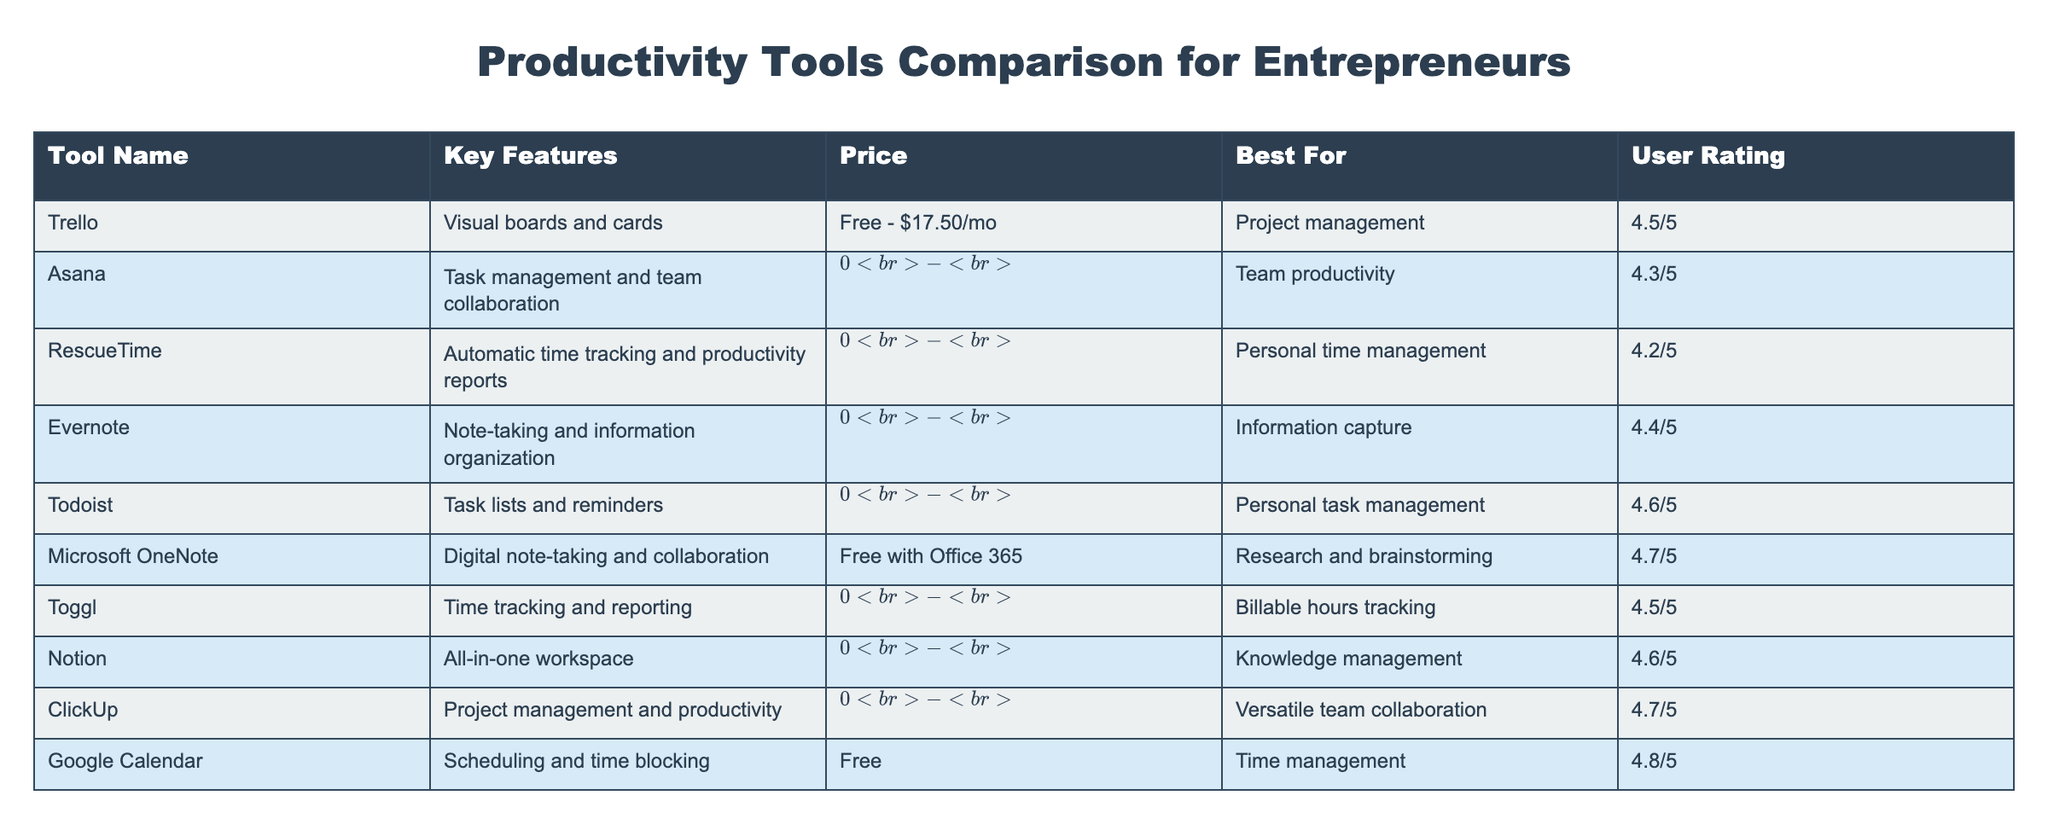What is the price of Microsoft OneNote? The table lists the price for Microsoft OneNote as "Free with Office 365." This information is found directly in the Price column corresponding to Microsoft OneNote.
Answer: Free with Office 365 Which tool has the highest user rating? To find the tool with the highest user rating, we need to compare the ratings in the User Rating column. Google Calendar has the highest rating at 4.8/5.
Answer: Google Calendar How many tools are available for free? Count the tools listed in the Price column that indicate they are free. The tools that are free include Trello, Microsoft OneNote, Google Calendar, and others; there are a total of 5 tools.
Answer: 5 What is the average user rating of all the tools listed in the table? To calculate the average rating, we need to sum up all user ratings: (4.5 + 4.3 + 4.2 + 4.4 + 4.6 + 4.7 + 4.5 + 4.6 + 4.7 + 4.8) = 46.3. Then divide by the total number of tools (10), giving us 46.3/10 = 4.63.
Answer: 4.63 Is Todoist more expensive than Evernote? To compare prices, we look at the relevant rows in the Price column. Todoist is listed at $0 - $5/mo, while Evernote's price is $0 - $14.99/mo. Therefore, Evernote is more expensive.
Answer: No Which tool is best for personal time management based on the table? By looking for tools listed as "Best For Personal Time Management" in the Best For column, we find that RescueTime is specifically mentioned for this category.
Answer: RescueTime What is the price difference between Asana and ClickUp? Asana's price is listed as $0 - $24.99/user/mo and ClickUp's price is $0 - $19/user/mo. The price difference is calculated by finding the maximum price for Asana ($24.99) and subtracting the maximum price for ClickUp ($19), resulting in $24.99 - $19 = $5.99.
Answer: $5.99 Do any of the productivity tools offer automatic time tracking? To determine this, we check the Key Features column for the phrase "automatic time tracking." RescueTime is the only tool listed that includes this feature.
Answer: Yes Which tool is best for scheduling and time blocking? According to the table, Google Calendar is listed as the best tool for scheduling and time blocking in the Best For column.
Answer: Google Calendar 